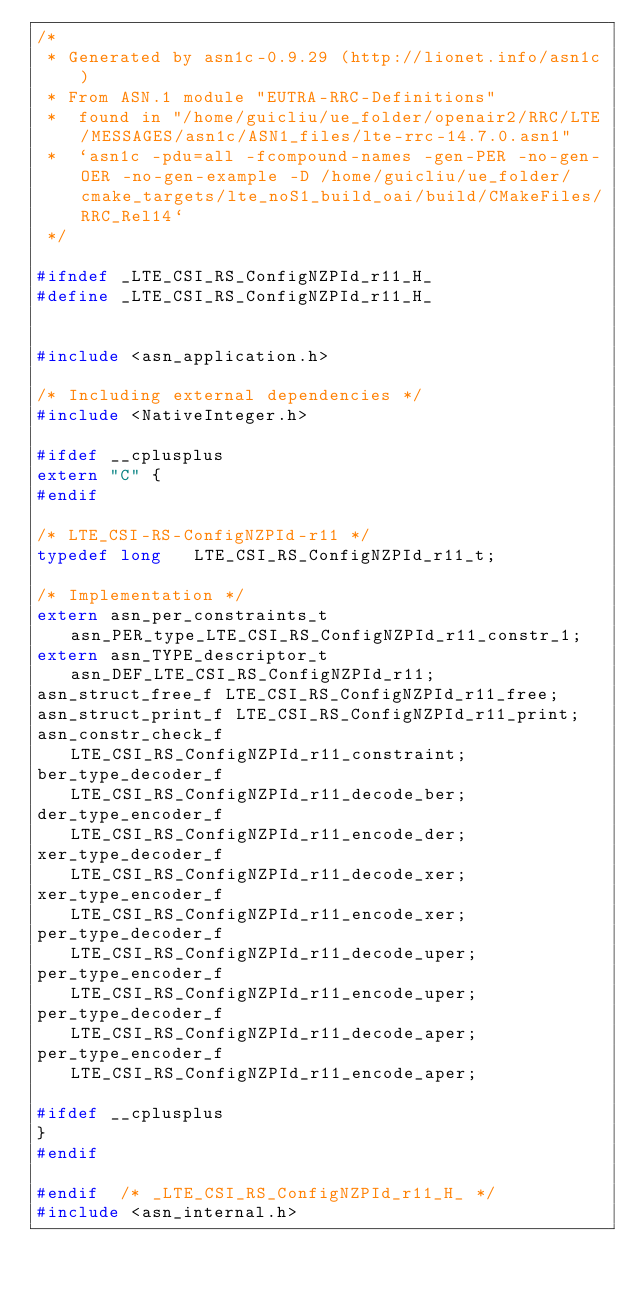<code> <loc_0><loc_0><loc_500><loc_500><_C_>/*
 * Generated by asn1c-0.9.29 (http://lionet.info/asn1c)
 * From ASN.1 module "EUTRA-RRC-Definitions"
 * 	found in "/home/guicliu/ue_folder/openair2/RRC/LTE/MESSAGES/asn1c/ASN1_files/lte-rrc-14.7.0.asn1"
 * 	`asn1c -pdu=all -fcompound-names -gen-PER -no-gen-OER -no-gen-example -D /home/guicliu/ue_folder/cmake_targets/lte_noS1_build_oai/build/CMakeFiles/RRC_Rel14`
 */

#ifndef	_LTE_CSI_RS_ConfigNZPId_r11_H_
#define	_LTE_CSI_RS_ConfigNZPId_r11_H_


#include <asn_application.h>

/* Including external dependencies */
#include <NativeInteger.h>

#ifdef __cplusplus
extern "C" {
#endif

/* LTE_CSI-RS-ConfigNZPId-r11 */
typedef long	 LTE_CSI_RS_ConfigNZPId_r11_t;

/* Implementation */
extern asn_per_constraints_t asn_PER_type_LTE_CSI_RS_ConfigNZPId_r11_constr_1;
extern asn_TYPE_descriptor_t asn_DEF_LTE_CSI_RS_ConfigNZPId_r11;
asn_struct_free_f LTE_CSI_RS_ConfigNZPId_r11_free;
asn_struct_print_f LTE_CSI_RS_ConfigNZPId_r11_print;
asn_constr_check_f LTE_CSI_RS_ConfigNZPId_r11_constraint;
ber_type_decoder_f LTE_CSI_RS_ConfigNZPId_r11_decode_ber;
der_type_encoder_f LTE_CSI_RS_ConfigNZPId_r11_encode_der;
xer_type_decoder_f LTE_CSI_RS_ConfigNZPId_r11_decode_xer;
xer_type_encoder_f LTE_CSI_RS_ConfigNZPId_r11_encode_xer;
per_type_decoder_f LTE_CSI_RS_ConfigNZPId_r11_decode_uper;
per_type_encoder_f LTE_CSI_RS_ConfigNZPId_r11_encode_uper;
per_type_decoder_f LTE_CSI_RS_ConfigNZPId_r11_decode_aper;
per_type_encoder_f LTE_CSI_RS_ConfigNZPId_r11_encode_aper;

#ifdef __cplusplus
}
#endif

#endif	/* _LTE_CSI_RS_ConfigNZPId_r11_H_ */
#include <asn_internal.h>
</code> 